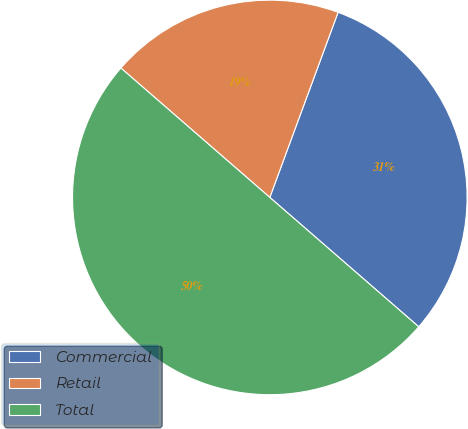Convert chart to OTSL. <chart><loc_0><loc_0><loc_500><loc_500><pie_chart><fcel>Commercial<fcel>Retail<fcel>Total<nl><fcel>30.76%<fcel>19.24%<fcel>50.0%<nl></chart> 